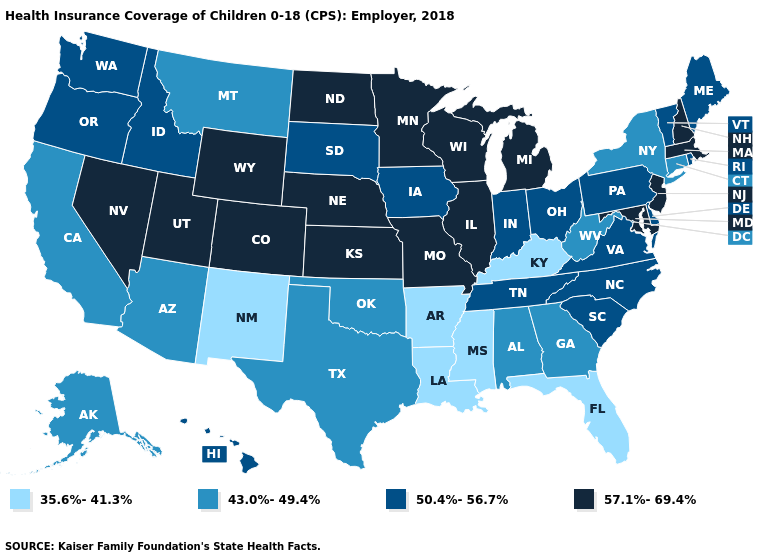Among the states that border Ohio , which have the lowest value?
Answer briefly. Kentucky. Among the states that border New Jersey , does New York have the lowest value?
Answer briefly. Yes. Which states have the lowest value in the West?
Quick response, please. New Mexico. Name the states that have a value in the range 35.6%-41.3%?
Be succinct. Arkansas, Florida, Kentucky, Louisiana, Mississippi, New Mexico. What is the value of Colorado?
Be succinct. 57.1%-69.4%. Does Tennessee have a higher value than Ohio?
Concise answer only. No. Name the states that have a value in the range 57.1%-69.4%?
Keep it brief. Colorado, Illinois, Kansas, Maryland, Massachusetts, Michigan, Minnesota, Missouri, Nebraska, Nevada, New Hampshire, New Jersey, North Dakota, Utah, Wisconsin, Wyoming. What is the highest value in the USA?
Keep it brief. 57.1%-69.4%. Which states have the lowest value in the USA?
Concise answer only. Arkansas, Florida, Kentucky, Louisiana, Mississippi, New Mexico. Does Nevada have a higher value than Minnesota?
Keep it brief. No. Does Oklahoma have the highest value in the USA?
Give a very brief answer. No. Does Ohio have the lowest value in the MidWest?
Quick response, please. Yes. Name the states that have a value in the range 57.1%-69.4%?
Concise answer only. Colorado, Illinois, Kansas, Maryland, Massachusetts, Michigan, Minnesota, Missouri, Nebraska, Nevada, New Hampshire, New Jersey, North Dakota, Utah, Wisconsin, Wyoming. What is the value of Arizona?
Give a very brief answer. 43.0%-49.4%. Name the states that have a value in the range 50.4%-56.7%?
Concise answer only. Delaware, Hawaii, Idaho, Indiana, Iowa, Maine, North Carolina, Ohio, Oregon, Pennsylvania, Rhode Island, South Carolina, South Dakota, Tennessee, Vermont, Virginia, Washington. 